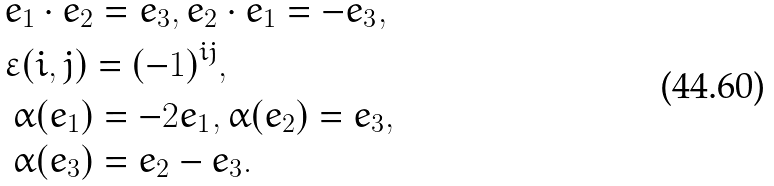Convert formula to latex. <formula><loc_0><loc_0><loc_500><loc_500>& e _ { 1 } \cdot e _ { 2 } = e _ { 3 } , e _ { 2 } \cdot e _ { 1 } = - e _ { 3 } , \\ & \varepsilon ( i , j ) = ( - 1 ) ^ { i j } , \\ & \begin{array} [ t ] { l } \alpha ( e _ { 1 } ) = - 2 e _ { 1 } , \alpha ( e _ { 2 } ) = e _ { 3 } , \\ \alpha ( e _ { 3 } ) = e _ { 2 } - e _ { 3 } . \end{array}</formula> 